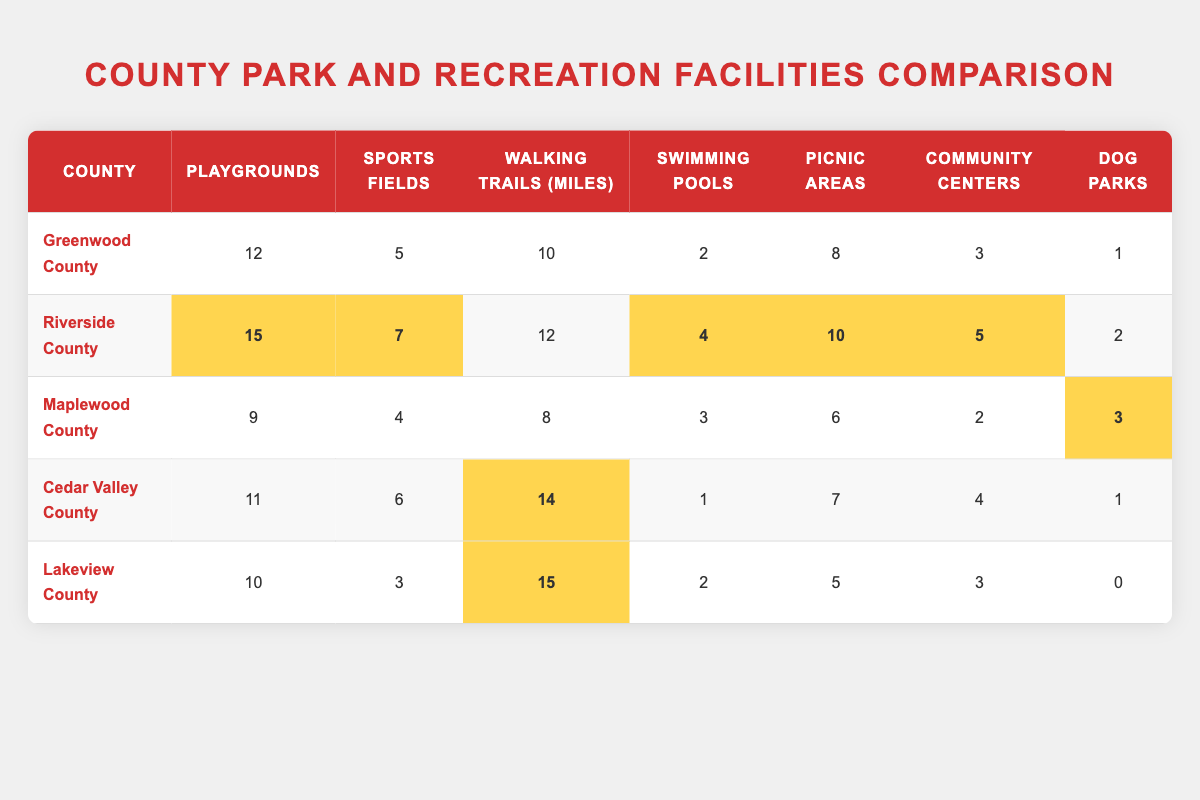What county has the most playgrounds? By examining the "Playgrounds" column, Riverside County has 15 playgrounds, which is the highest number compared to the other counties.
Answer: Riverside County Which county has the fewest dog parks? The "Dog Parks" column shows that Lakeview County has 0 dog parks, which is lower than any other county.
Answer: Lakeview County How many sports fields are there in Cedar Valley County? Looking directly at the row for Cedar Valley County, it shows there are 6 sports fields.
Answer: 6 What is the total number of swimming pools across all counties? To find the total, add the swimming pools from each county: 2 (Greenwood) + 4 (Riverside) + 3 (Maplewood) + 1 (Cedar Valley) + 2 (Lakeview) = 12.
Answer: 12 Is Maplewood County ranked highest for walking trails? Based on the "Walking Trails (miles)" column, Cedar Valley County has the highest at 14 miles, so Maplewood is not ranked highest.
Answer: No Which county offers the most picnic areas? Riverside County has 10 picnic areas, which is more than any other county listed, making it the offering the most.
Answer: Riverside County What is the average number of community centers across all counties? The total number of community centers is calculated as follows: 3 (Greenwood) + 5 (Riverside) + 2 (Maplewood) + 4 (Cedar Valley) + 3 (Lakeview) = 17. Then divide by the number of counties (5): 17 / 5 = 3.4.
Answer: 3.4 How many more sports fields does Riverside County have than Maplewood County? Riverside County has 7 sports fields whereas Maplewood County has 4. The difference is 7 - 4 = 3, meaning Riverside has 3 more sports fields.
Answer: 3 Which county has the highest total of parks and recreation amenities (sum of all the amenities)? For each county, we sum the values: For example, Riverside County's total is 15 + 7 + 12 + 4 + 10 + 5 + 2 = 55, while others' totals are lower. After calculating for all, the highest total is 55 for Riverside.
Answer: Riverside County 